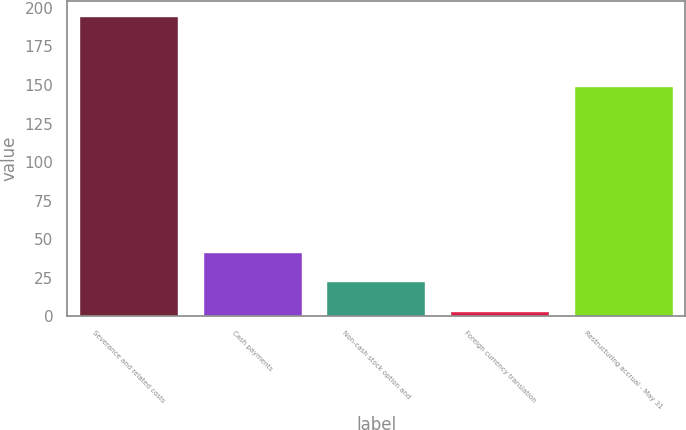Convert chart. <chart><loc_0><loc_0><loc_500><loc_500><bar_chart><fcel>Severance and related costs<fcel>Cash payments<fcel>Non-cash stock option and<fcel>Foreign currency translation<fcel>Restructuring accrual - May 31<nl><fcel>195<fcel>41.8<fcel>22.65<fcel>3.5<fcel>149.6<nl></chart> 